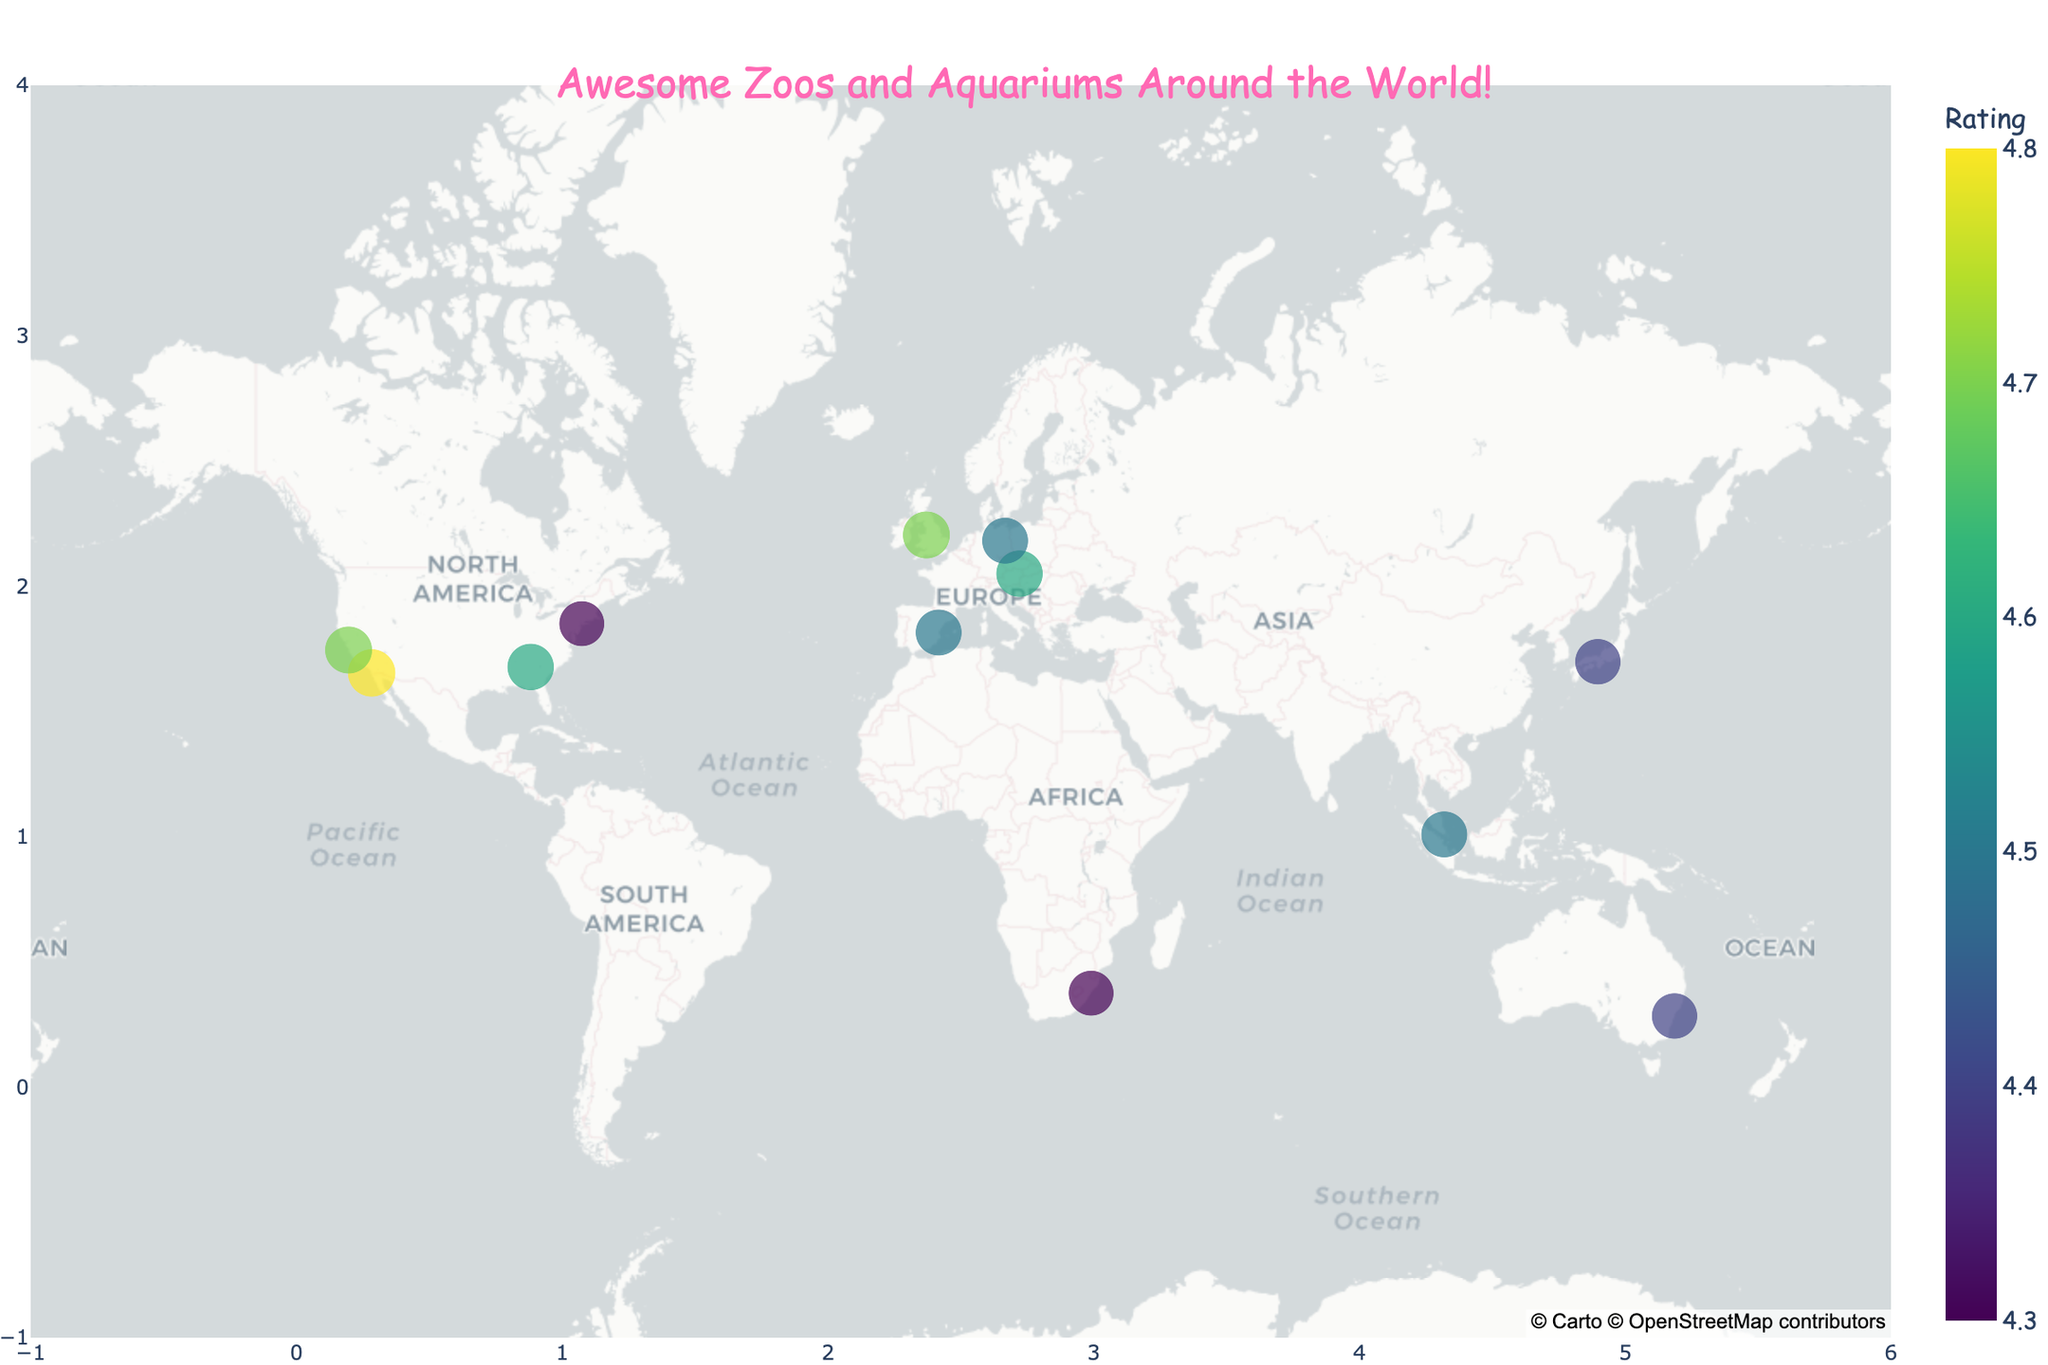What's the name of the zoo located in San Diego? The name of the zoo located at the latitude 32.7353 and longitude -117.1490 is visible on the map, which is in San Diego.
Answer: San Diego Zoo Which zoo or aquarium has the highest visitor rating? Looking at the ratings associated with each zoo or aquarium on the map, the one with the highest rating is shown to be 4.8.
Answer: San Diego Zoo How many zoos and aquariums have a rating of 4.5 or higher? By examining the colors and ratings marked on each location, count the number of places where the rating is 4.5 or higher. These are San Diego Zoo, Singapore Zoo, Chester Zoo, Tiergarten Schönbrunn, Berlin Zoological Garden, Monterey Bay Aquarium, and Georgia Aquarium.
Answer: 7 Which animal is highlighted at the L'Oceanogràfic aquarium? The animal highlighted for L'Oceanogràfic, indicated on the map near its location in Valencia, Spain, is shown in the hover info as "Beluga Whales".
Answer: Beluga Whales Between the Bronx Zoo and the Chester Zoo, which one has a higher visitor rating? Compare the ratings. The Bronx Zoo has a rating of 4.3, while Chester Zoo has a rating of 4.7.
Answer: Chester Zoo What is the rating difference between Taronga Zoo Sydney and Osaka Aquarium Kaiyukan? The rating for Taronga Zoo Sydney is 4.4, and for Osaka Aquarium Kaiyukan it is also 4.4. The difference can be calculated as 4.4 - 4.4.
Answer: 0 Which zoo is closest to the equator? Look for the latitude values closest to 0. The Singapore Zoo, with a latitude of 1.4043, is closest to the equator.
Answer: Singapore Zoo How many zoos or aquariums are located in Europe? By observing the map and identifying the locations in Europe, we can see that the Chester Zoo, Tiergarten Schönbrunn, Berlin Zoological Garden, and L'Oceanogràfic are the ones in Europe.
Answer: 4 Which zoo or aquarium features polar bears as their highlight? The Berlin Zoological Garden is shown to have Polar Bears as their highlighted animal.
Answer: Berlin Zoological Garden Among the U.S.-based zoos/aquariums listed, which has the highest rating? Comparing the ratings of the zoos and aquariums in the U.S., San Diego Zoo and Monterey Bay Aquarium both have the highest rating of 4.8 and 4.7 respectively.
Answer: San Diego Zoo 